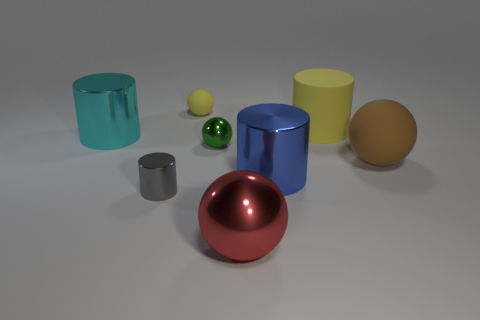Subtract all gray metallic cylinders. How many cylinders are left? 3 Subtract all blue cylinders. How many cylinders are left? 3 Add 1 large objects. How many objects exist? 9 Subtract 3 spheres. How many spheres are left? 1 Subtract all gray spheres. Subtract all red cylinders. How many spheres are left? 4 Subtract all yellow spheres. How many green cylinders are left? 0 Subtract all large cyan shiny objects. Subtract all cyan shiny cylinders. How many objects are left? 6 Add 2 large objects. How many large objects are left? 7 Add 3 tiny gray rubber blocks. How many tiny gray rubber blocks exist? 3 Subtract 1 blue cylinders. How many objects are left? 7 